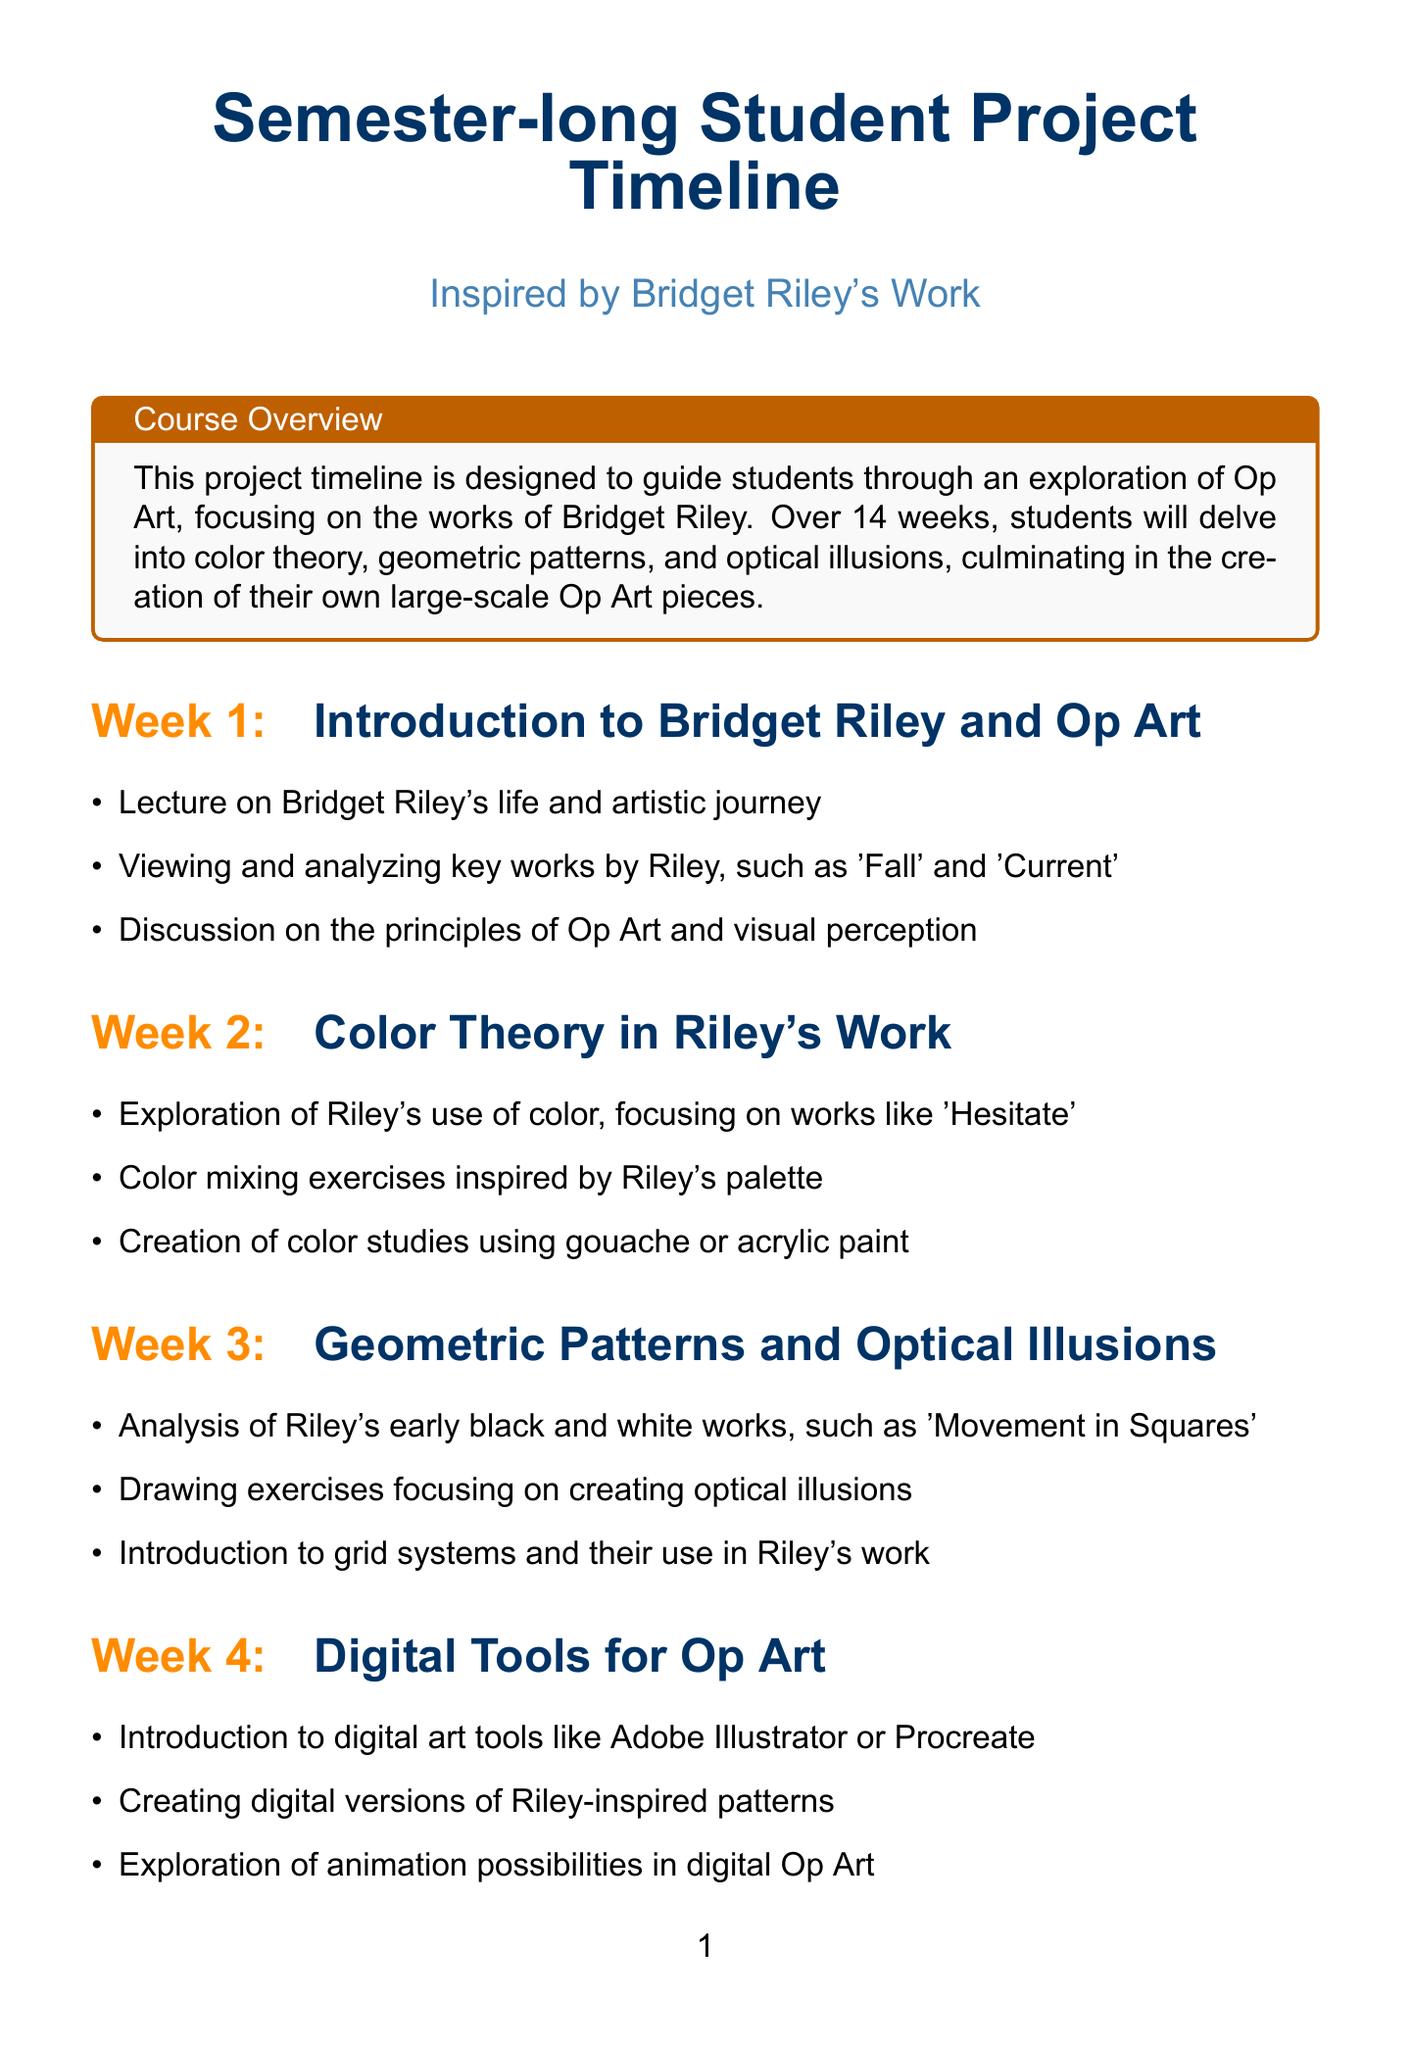What is the total number of weeks in the project timeline? The timeline consists of a total of 14 weeks, as indicated in the document.
Answer: 14 Which artwork by Bridget Riley is focused on in week 2? Week 2 explores the use of color in Riley's work, particularly focusing on the artwork 'Hesitate'.
Answer: 'Hesitate' What is the topic for week 8? Week 8 is dedicated to the mid-semester critique, where students assess work-in-progress and receive feedback.
Answer: Mid-Semester Critique In which week do students start individual work on projects? Individual work on large-scale projects begins in week 7, allowing students to develop their ideas further.
Answer: Week 7 What concept is introduced in week 3? Week 3 introduces the creation of geometric patterns and optical illusions, key elements in Op Art.
Answer: Geometric Patterns and Optical Illusions What type of critique occurs in week 11? Week 11 involves peer feedback sessions, allowing students to share and refine their project ideas.
Answer: Peer feedback sessions Which art tools are introduced in week 4? Digital art tools such as Adobe Illustrator or Procreate are introduced to students for creating digital patterns in week 4.
Answer: Adobe Illustrator or Procreate What activity occurs during week 12 regarding artist statements? A workshop is conducted in week 12 to guide students in writing their artist statements effectively.
Answer: Workshop on writing artist statements What is the focus of the final presentation in week 14? The final presentations in week 14 focus on reflecting on the full semester and showcasing individual projects through a classroom exhibition.
Answer: Classroom exhibition 